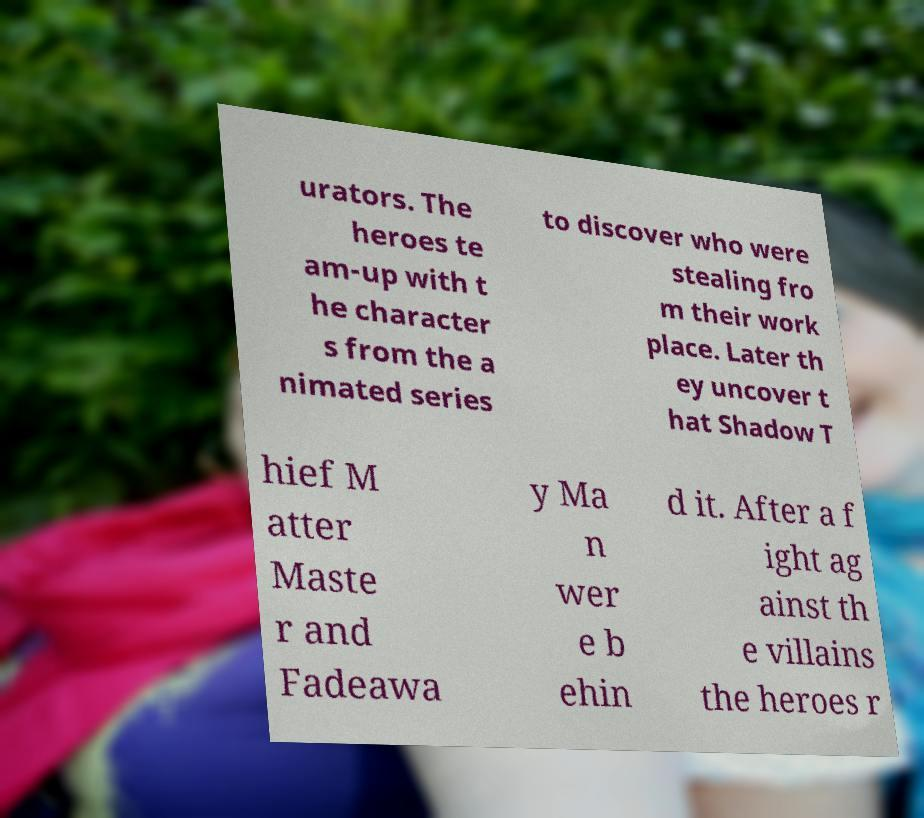Please identify and transcribe the text found in this image. urators. The heroes te am-up with t he character s from the a nimated series to discover who were stealing fro m their work place. Later th ey uncover t hat Shadow T hief M atter Maste r and Fadeawa y Ma n wer e b ehin d it. After a f ight ag ainst th e villains the heroes r 